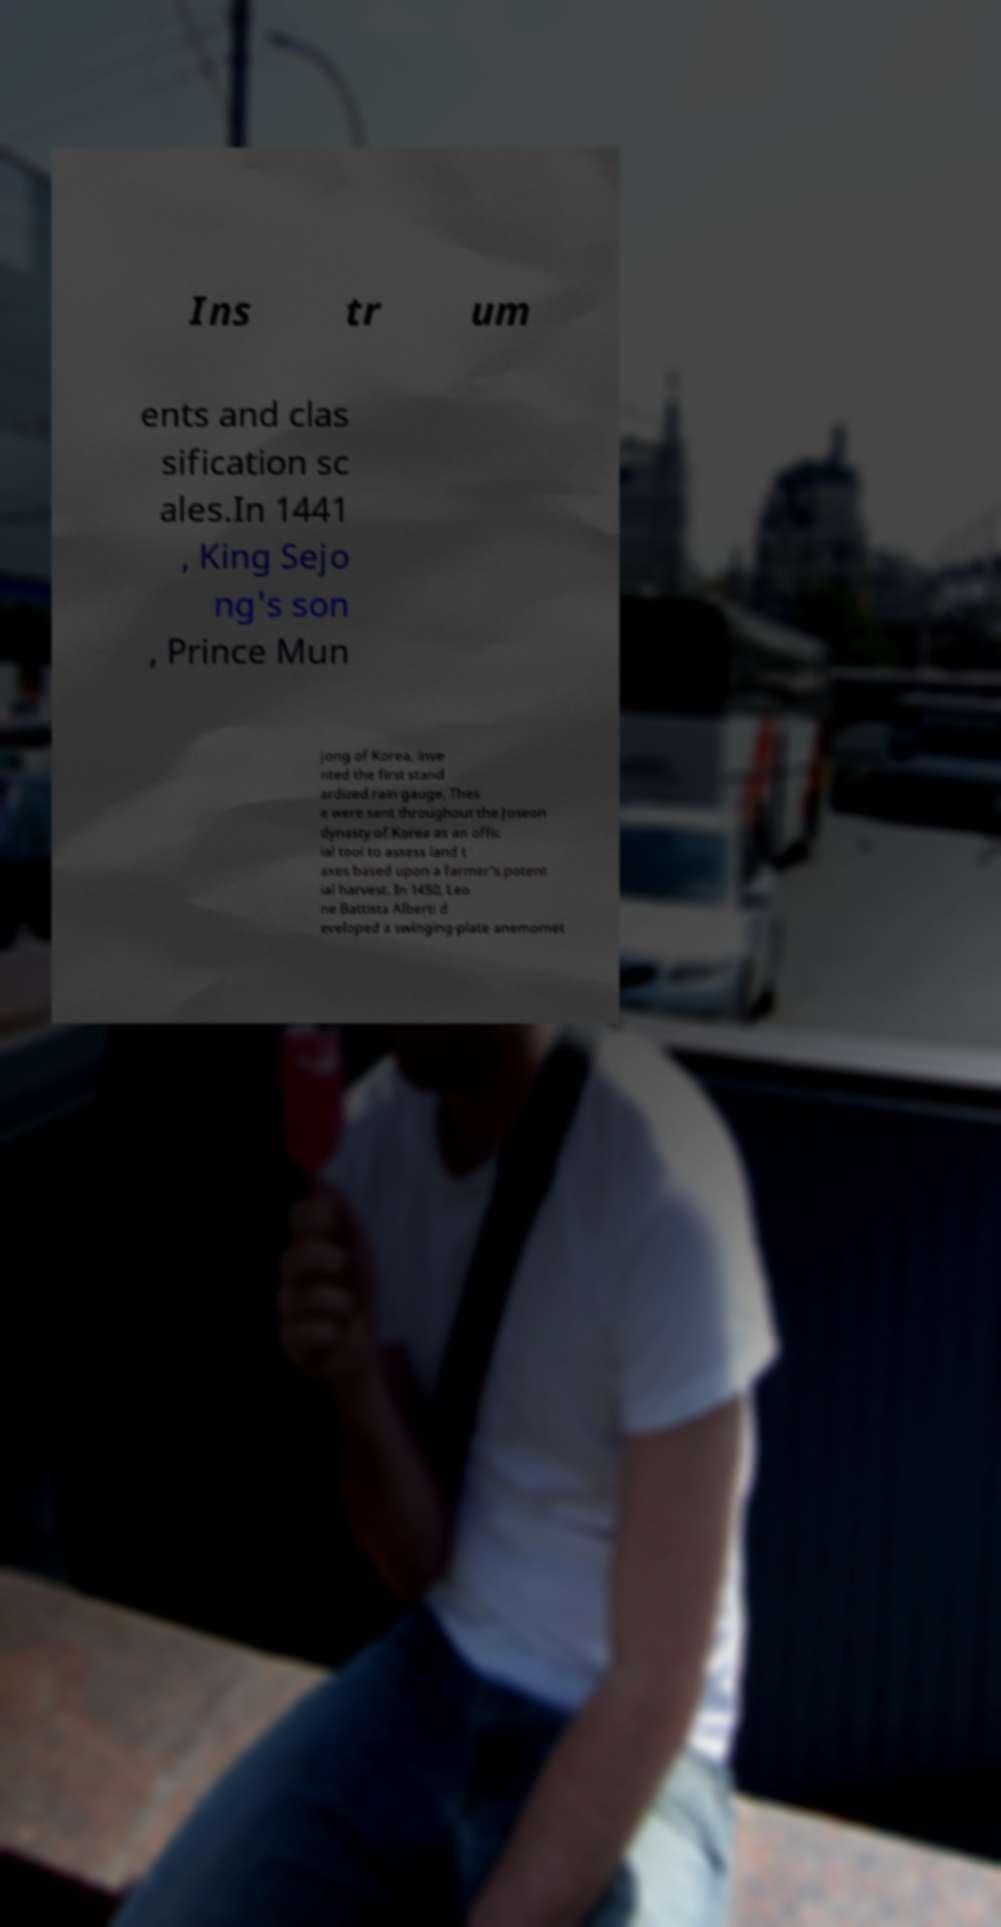Please identify and transcribe the text found in this image. Ins tr um ents and clas sification sc ales.In 1441 , King Sejo ng's son , Prince Mun jong of Korea, inve nted the first stand ardized rain gauge. Thes e were sent throughout the Joseon dynasty of Korea as an offic ial tool to assess land t axes based upon a farmer's potent ial harvest. In 1450, Leo ne Battista Alberti d eveloped a swinging-plate anemomet 